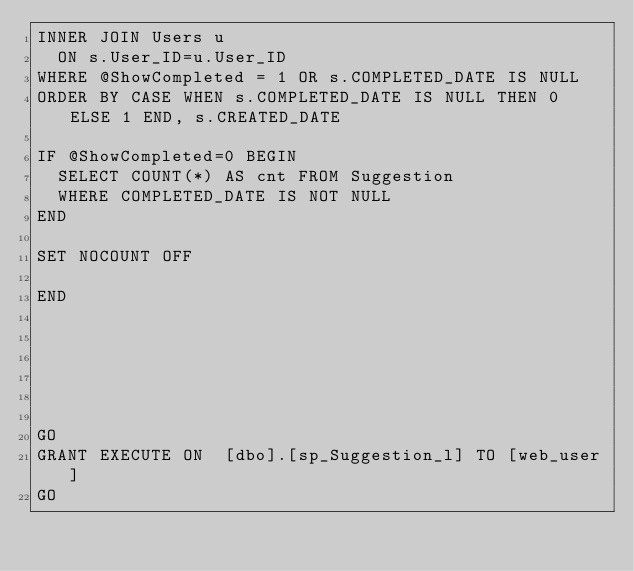Convert code to text. <code><loc_0><loc_0><loc_500><loc_500><_SQL_>INNER JOIN Users u
	ON s.User_ID=u.User_ID
WHERE @ShowCompleted = 1 OR s.COMPLETED_DATE IS NULL
ORDER BY CASE WHEN s.COMPLETED_DATE IS NULL THEN 0 ELSE 1 END, s.CREATED_DATE

IF @ShowCompleted=0 BEGIN
	SELECT COUNT(*) AS cnt FROM Suggestion
	WHERE COMPLETED_DATE IS NOT NULL
END

SET NOCOUNT OFF

END






GO
GRANT EXECUTE ON  [dbo].[sp_Suggestion_l] TO [web_user]
GO
</code> 